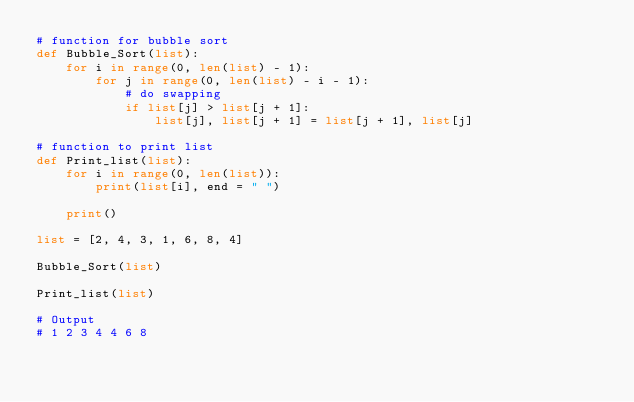Convert code to text. <code><loc_0><loc_0><loc_500><loc_500><_Python_># function for bubble sort
def Bubble_Sort(list):
    for i in range(0, len(list) - 1):
        for j in range(0, len(list) - i - 1):
            # do swapping
            if list[j] > list[j + 1]:
                list[j], list[j + 1] = list[j + 1], list[j]

# function to print list
def Print_list(list):
    for i in range(0, len(list)):
        print(list[i], end = " ")

    print()

list = [2, 4, 3, 1, 6, 8, 4]

Bubble_Sort(list)

Print_list(list)

# Output
# 1 2 3 4 4 6 8
</code> 